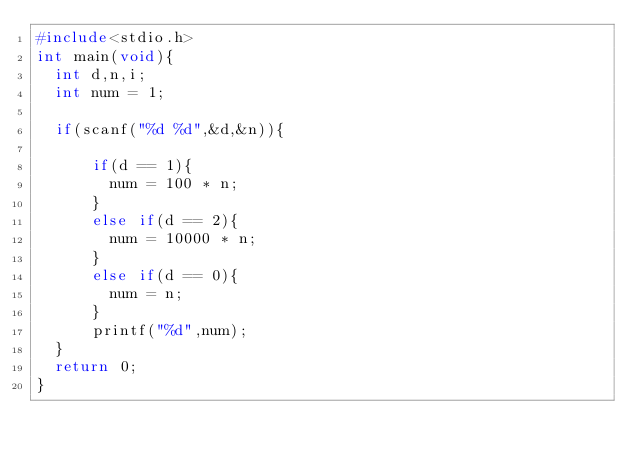<code> <loc_0><loc_0><loc_500><loc_500><_C_>#include<stdio.h>
int main(void){
  int d,n,i;
  int num = 1;
  
  if(scanf("%d %d",&d,&n)){
  
      if(d == 1){
        num = 100 * n;
      }
      else if(d == 2){
        num = 10000 * n;
      }
      else if(d == 0){
        num = n;
      }
      printf("%d",num);
  }
  return 0;
}</code> 